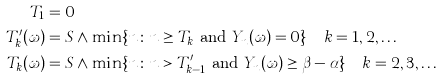<formula> <loc_0><loc_0><loc_500><loc_500>T _ { 1 } & = 0 \\ T ^ { \prime } _ { k } ( \omega ) & = S \wedge \min \{ n \colon n \geq T _ { k } \text { and } Y _ { n } ( \omega ) = 0 \} \quad k = 1 , 2 , \dots \\ T _ { k } ( \omega ) & = S \wedge \min \{ n \colon n > T ^ { \prime } _ { k - 1 } \text { and } Y _ { n } ( \omega ) \geq \beta - \alpha \} \quad k = 2 , 3 , \dots \\</formula> 